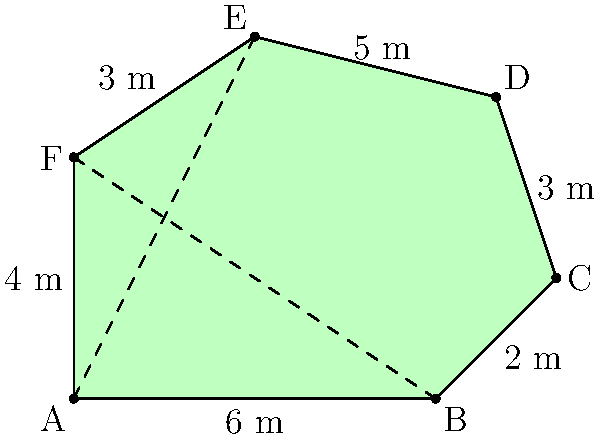You have an irregularly-shaped field for crop planning, as shown in the diagram. The field is divided into two triangles by the dashed lines. Given the measurements provided, calculate the total area of the field in square meters. To find the area of the irregularly-shaped field, we can divide it into two triangles and calculate their areas separately:

1. Triangle ABE:
   Base = 6 m
   Height = 6 m
   Area of ABE = $\frac{1}{2} \times 6 \times 6 = 18$ m²

2. Triangle BCF:
   Base = 8 m
   Height = 4 m
   Area of BCF = $\frac{1}{2} \times 8 \times 4 = 16$ m²

3. Total area of the field:
   Total Area = Area of ABE + Area of BCF
               = 18 m² + 16 m²
               = 34 m²

Therefore, the total area of the irregularly-shaped field is 34 square meters.
Answer: 34 m² 